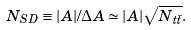Convert formula to latex. <formula><loc_0><loc_0><loc_500><loc_500>N _ { S D } \equiv | A | / { \mathit \Delta } A \simeq | A | \sqrt { N _ { t \bar { t } } } .</formula> 